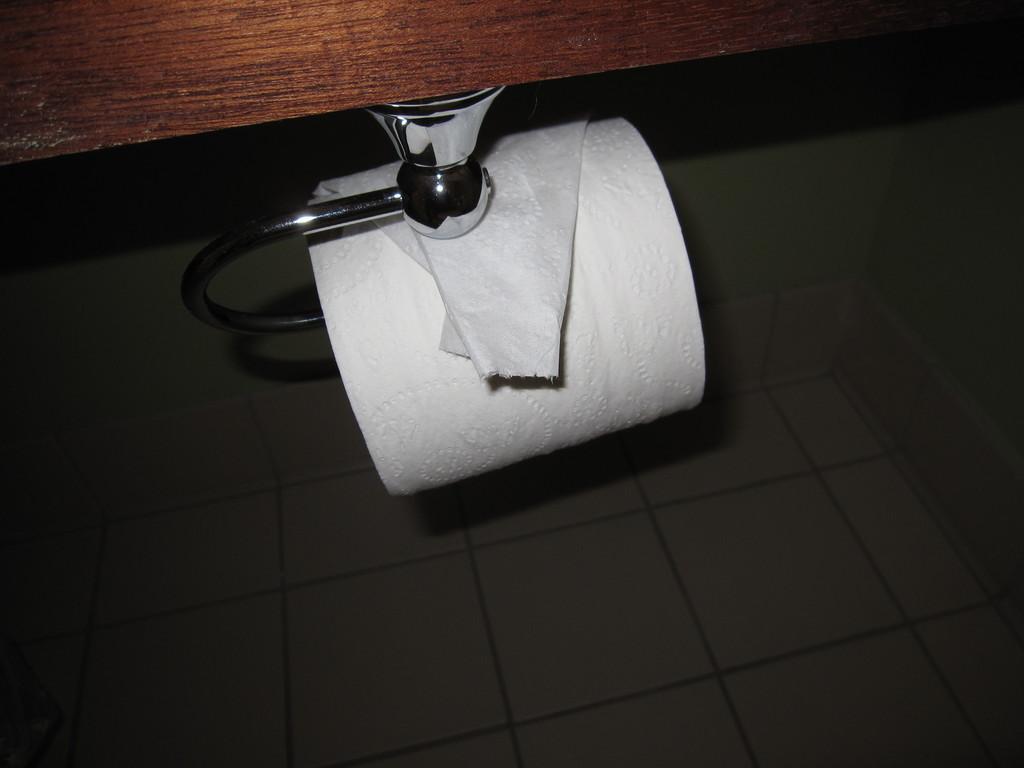How would you summarize this image in a sentence or two? In the center of the picture there is a tissue coil to a hanger. At the top there is a wooden object. At the bottom it is floor. 